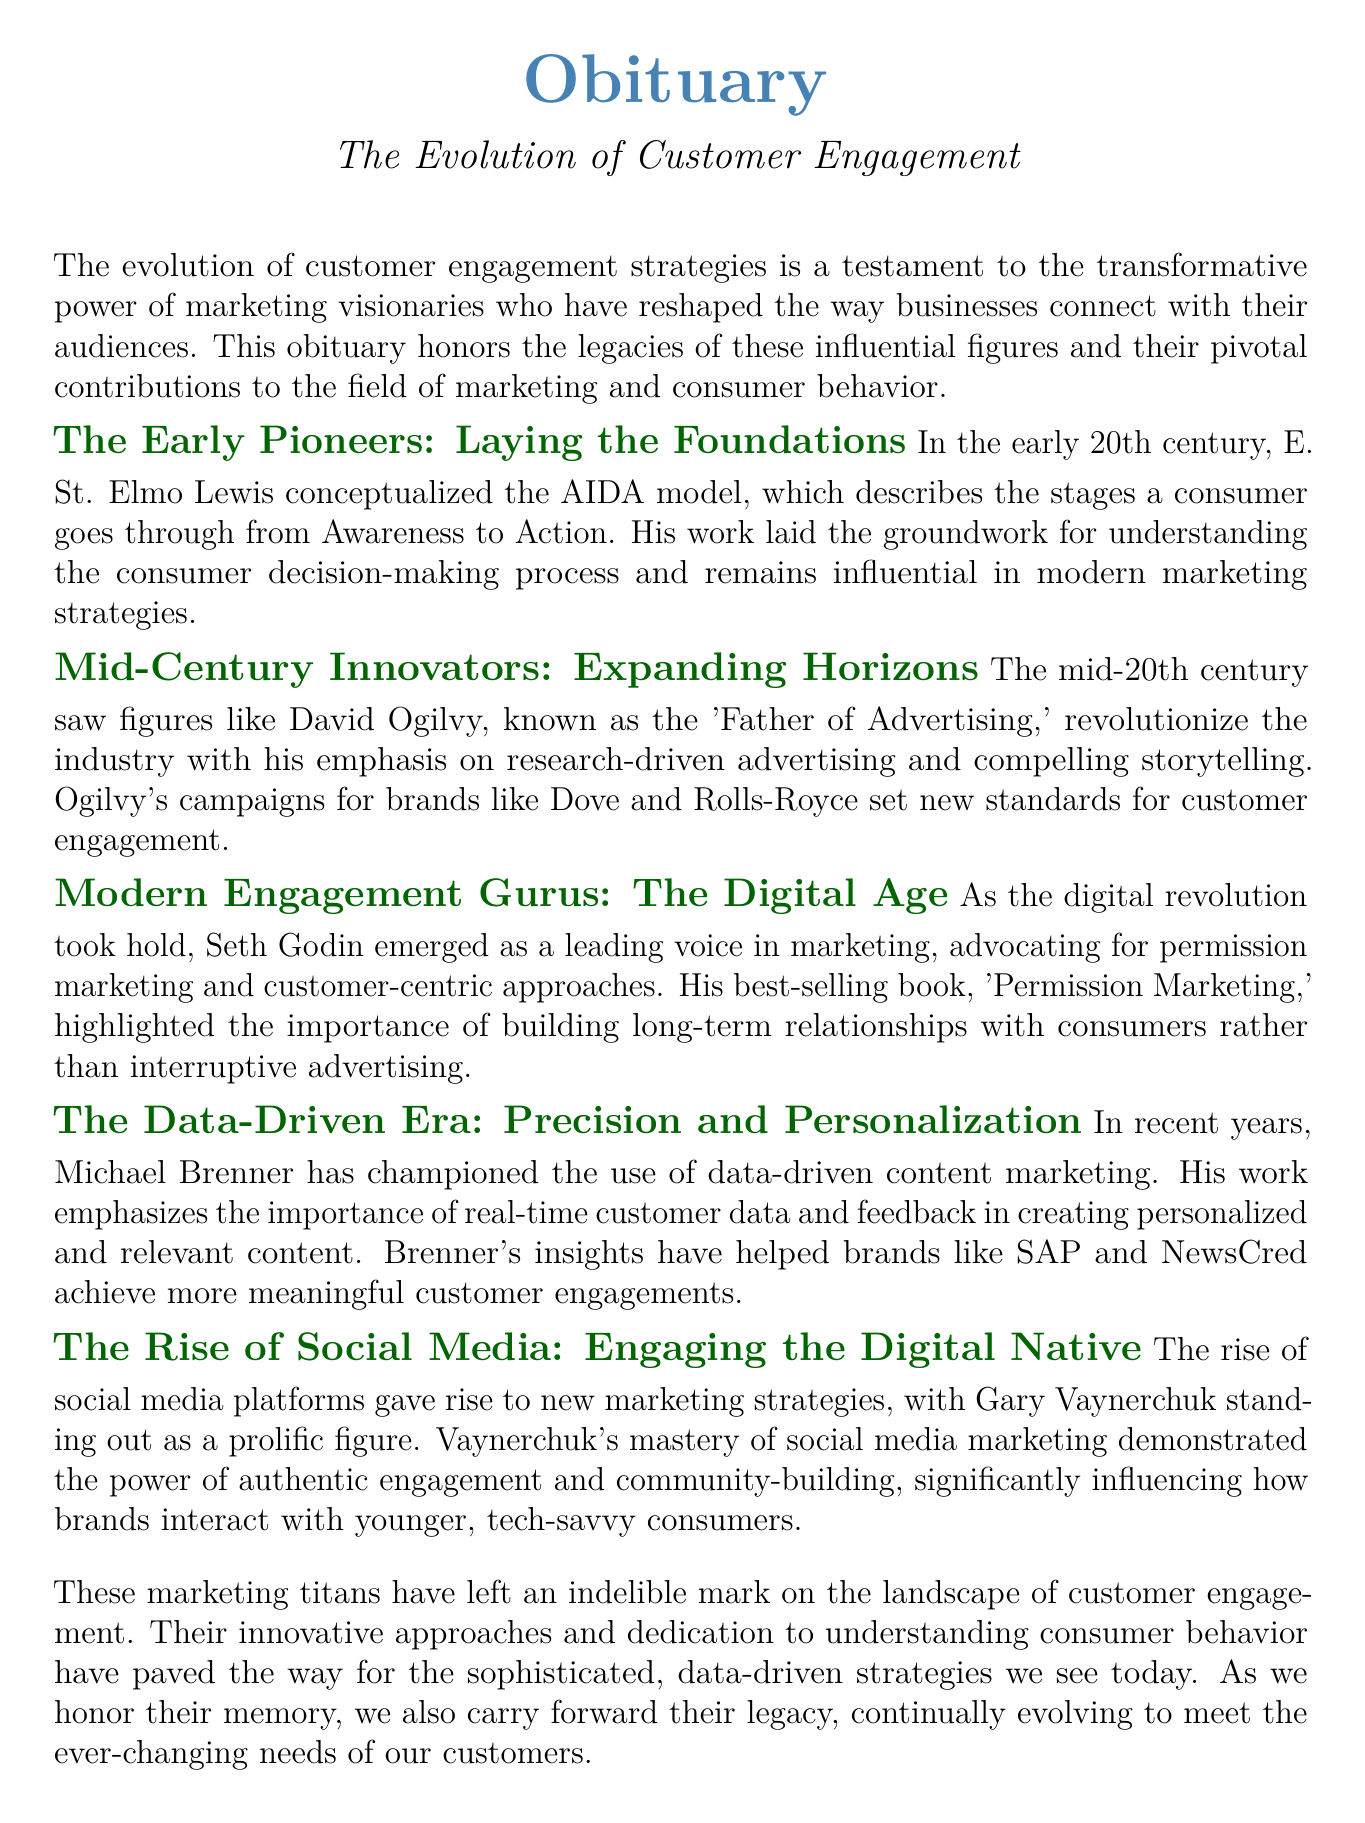What model did E. St. Elmo Lewis conceptualize? The document mentions that E. St. Elmo Lewis conceptualized the AIDA model, which describes the stages a consumer goes through from Awareness to Action.
Answer: AIDA model Who is known as the 'Father of Advertising'? According to the document, David Ogilvy is referred to as the 'Father of Advertising,' highlighting his significant contributions to the industry.
Answer: David Ogilvy What is the title of Seth Godin's best-selling book? The document states that Seth Godin wrote the best-selling book titled 'Permission Marketing,' which discusses customer-centric approaches.
Answer: Permission Marketing What type of marketing did Michael Brenner champion? The document explains that Michael Brenner has championed the use of data-driven content marketing, focusing on real-time customer data.
Answer: Data-driven content marketing Which figure emphasized authentic engagement in social media marketing? The document identifies Gary Vaynerchuk as a prolific figure in social media marketing who emphasized authentic engagement and community-building.
Answer: Gary Vaynerchuk What marked the beginning of modern customer engagement strategies? The early pioneers, such as E. St. Elmo Lewis with his AIDA model, are specified in the document as laying the foundation for modern customer engagement strategies.
Answer: Early pioneers Which marketing era is characterized by precision and personalization? The document highlights the data-driven era as the period characterized by precision and personalization in customer engagement strategies.
Answer: Data-driven era What transformative impact did marketing visionaries have on businesses? According to the document, marketing visionaries reshaped the way businesses connect with their audiences, demonstrating their transformative impact.
Answer: Reshaped connections 